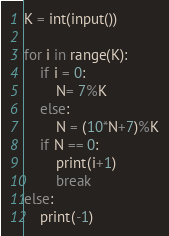<code> <loc_0><loc_0><loc_500><loc_500><_Python_>K = int(input())

for i in range(K):
    if i = 0:
        N= 7%K
    else:
        N = (10*N+7)%K
    if N == 0:
        print(i+1)
        break
else:
    print(-1)</code> 